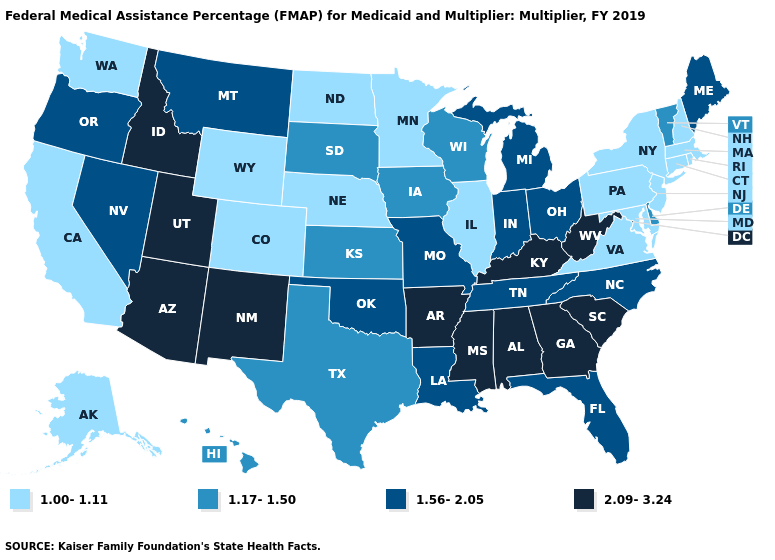What is the lowest value in states that border North Dakota?
Concise answer only. 1.00-1.11. What is the highest value in the USA?
Answer briefly. 2.09-3.24. Among the states that border Arkansas , which have the highest value?
Write a very short answer. Mississippi. Which states have the lowest value in the USA?
Keep it brief. Alaska, California, Colorado, Connecticut, Illinois, Maryland, Massachusetts, Minnesota, Nebraska, New Hampshire, New Jersey, New York, North Dakota, Pennsylvania, Rhode Island, Virginia, Washington, Wyoming. Name the states that have a value in the range 1.00-1.11?
Be succinct. Alaska, California, Colorado, Connecticut, Illinois, Maryland, Massachusetts, Minnesota, Nebraska, New Hampshire, New Jersey, New York, North Dakota, Pennsylvania, Rhode Island, Virginia, Washington, Wyoming. Does the map have missing data?
Write a very short answer. No. Does Indiana have the lowest value in the MidWest?
Quick response, please. No. Does Tennessee have the same value as Michigan?
Write a very short answer. Yes. Which states have the lowest value in the USA?
Write a very short answer. Alaska, California, Colorado, Connecticut, Illinois, Maryland, Massachusetts, Minnesota, Nebraska, New Hampshire, New Jersey, New York, North Dakota, Pennsylvania, Rhode Island, Virginia, Washington, Wyoming. Name the states that have a value in the range 1.17-1.50?
Concise answer only. Delaware, Hawaii, Iowa, Kansas, South Dakota, Texas, Vermont, Wisconsin. Among the states that border Minnesota , does Wisconsin have the highest value?
Short answer required. Yes. How many symbols are there in the legend?
Short answer required. 4. What is the lowest value in the MidWest?
Write a very short answer. 1.00-1.11. Does Idaho have the highest value in the USA?
Answer briefly. Yes. Which states hav the highest value in the Northeast?
Short answer required. Maine. 